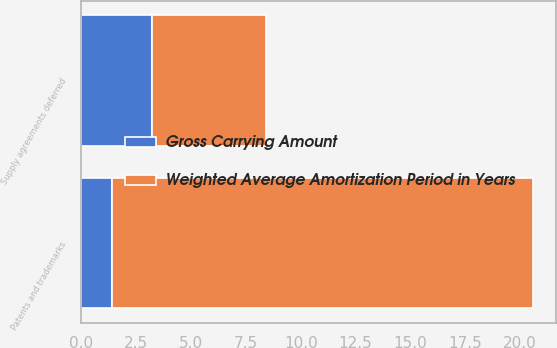<chart> <loc_0><loc_0><loc_500><loc_500><stacked_bar_chart><ecel><fcel>Patents and trademarks<fcel>Supply agreements deferred<nl><fcel>Gross Carrying Amount<fcel>1.4<fcel>3.2<nl><fcel>Weighted Average Amortization Period in Years<fcel>19.2<fcel>5.2<nl></chart> 